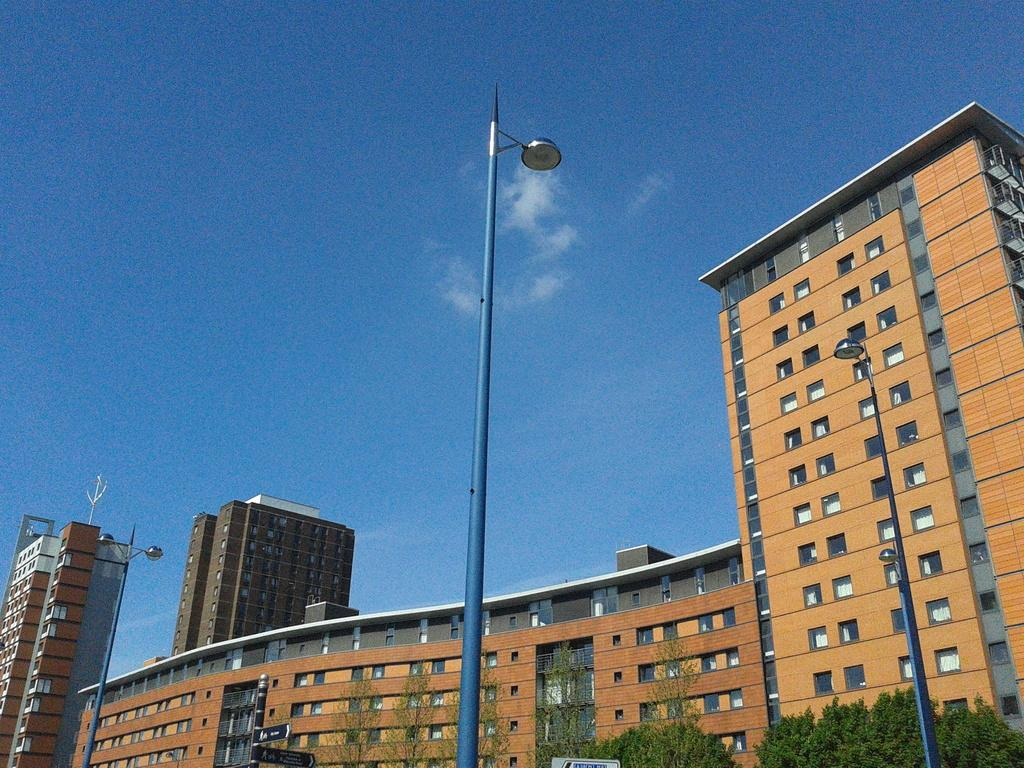What type of view is shown in the image? The image is an outside view. What structures can be seen in the image? There are poles and buildings visible in the image. What type of natural elements are present in the image? There are trees in the image. What is visible at the top of the image? The sky is visible at the top of the image. What type of shirt is hanging on the tree in the image? There is no shirt hanging on the tree in the image; it only features poles, buildings, trees, and the sky. 